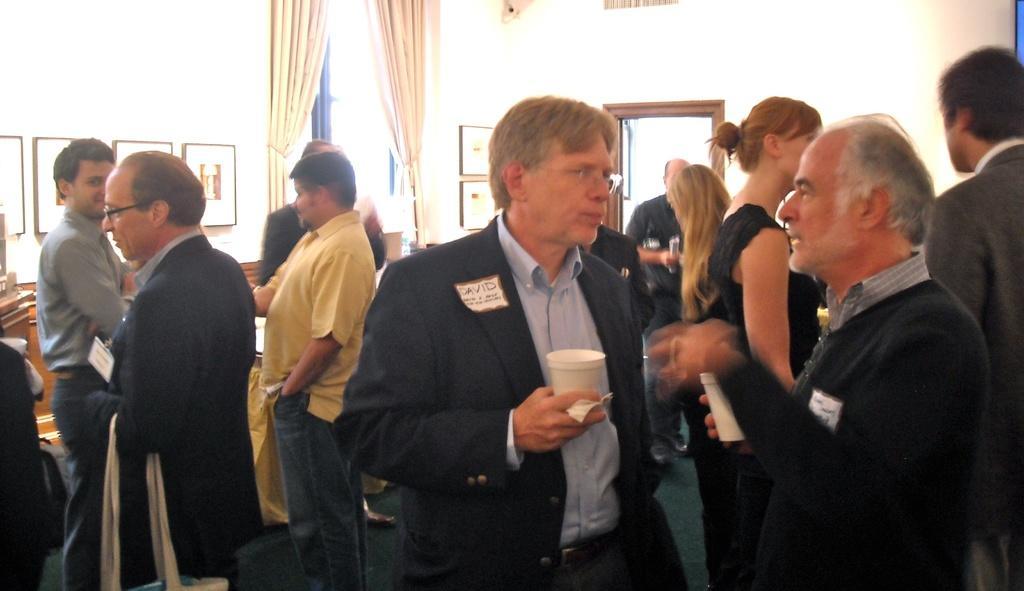Can you describe this image briefly? In this image we can see people standing and there are some people holding glasses. In the background there is a door and a curtain. We can see frames placed on the wall. 